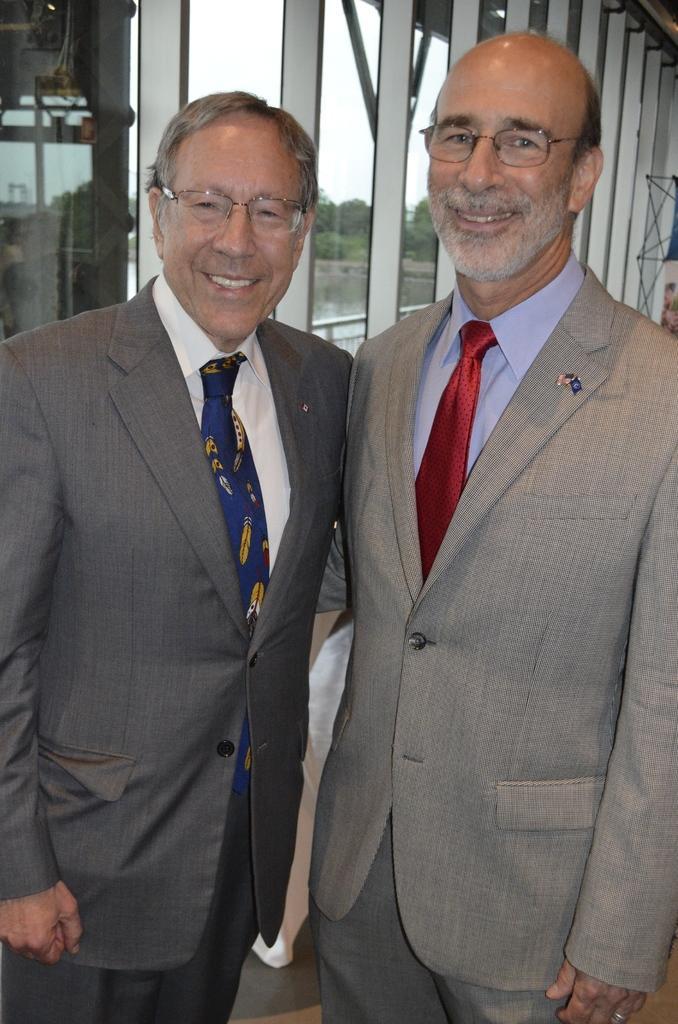Could you give a brief overview of what you see in this image? In this image in the front there are persons standing and smiling. In the background there are windows and behind the windows there are trees and there is water and there is a railing. 